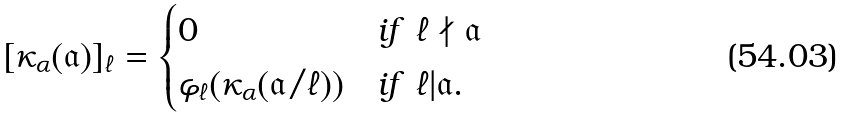<formula> <loc_0><loc_0><loc_500><loc_500>[ \kappa _ { \alpha } ( \mathfrak { a } ) ] _ { \ell } = \begin{cases} 0 & i f \ \ell \nmid \mathfrak { a } \\ \varphi _ { \ell } ( \kappa _ { \alpha } ( \mathfrak { a } / \ell ) ) & i f \ \ell | \mathfrak { a } . \end{cases}</formula> 